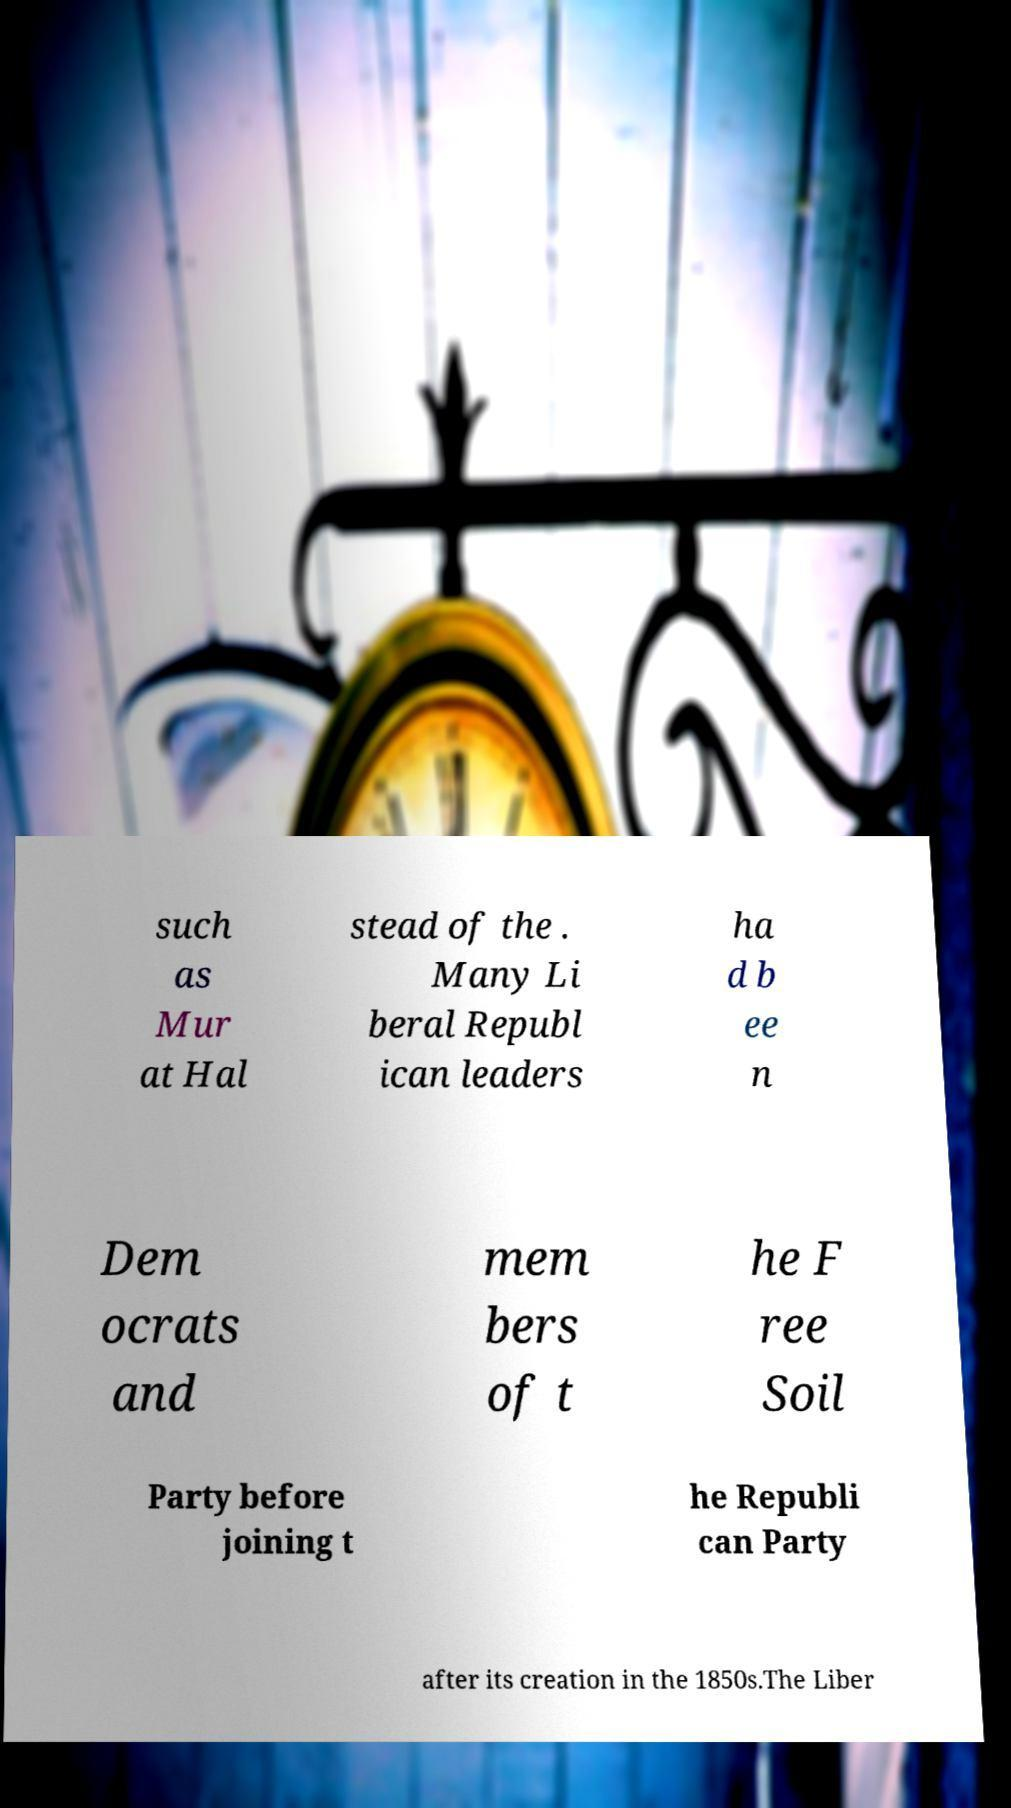Can you accurately transcribe the text from the provided image for me? such as Mur at Hal stead of the . Many Li beral Republ ican leaders ha d b ee n Dem ocrats and mem bers of t he F ree Soil Party before joining t he Republi can Party after its creation in the 1850s.The Liber 